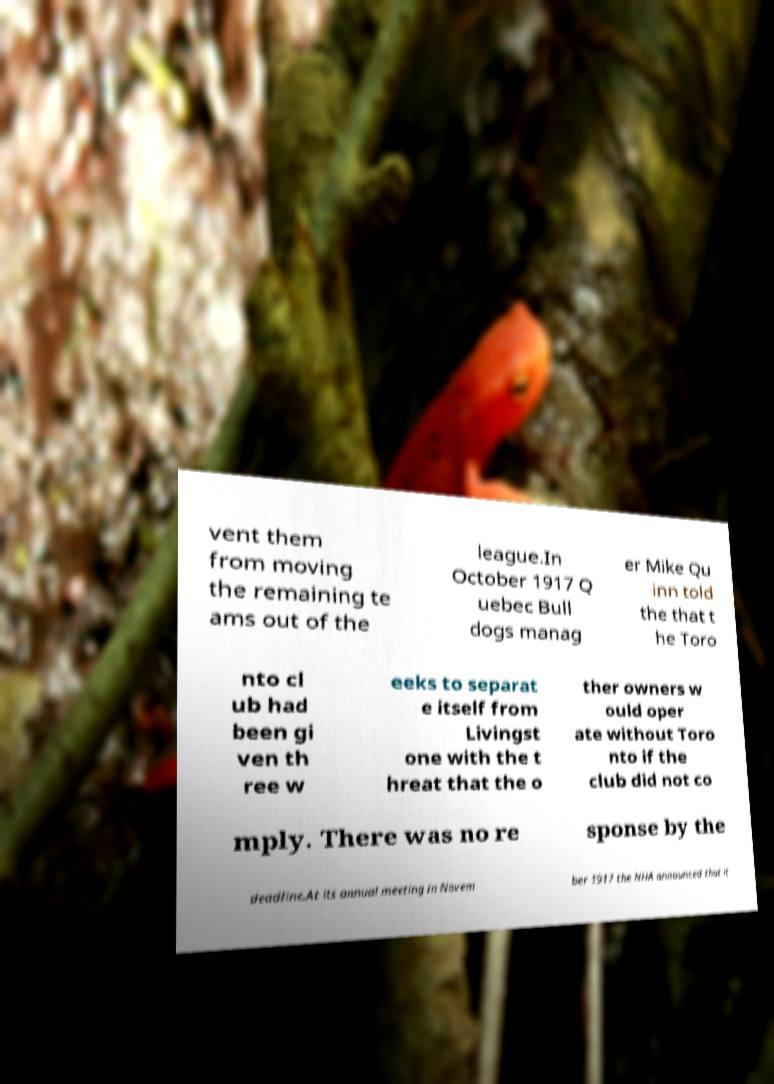Please read and relay the text visible in this image. What does it say? vent them from moving the remaining te ams out of the league.In October 1917 Q uebec Bull dogs manag er Mike Qu inn told the that t he Toro nto cl ub had been gi ven th ree w eeks to separat e itself from Livingst one with the t hreat that the o ther owners w ould oper ate without Toro nto if the club did not co mply. There was no re sponse by the deadline.At its annual meeting in Novem ber 1917 the NHA announced that it 